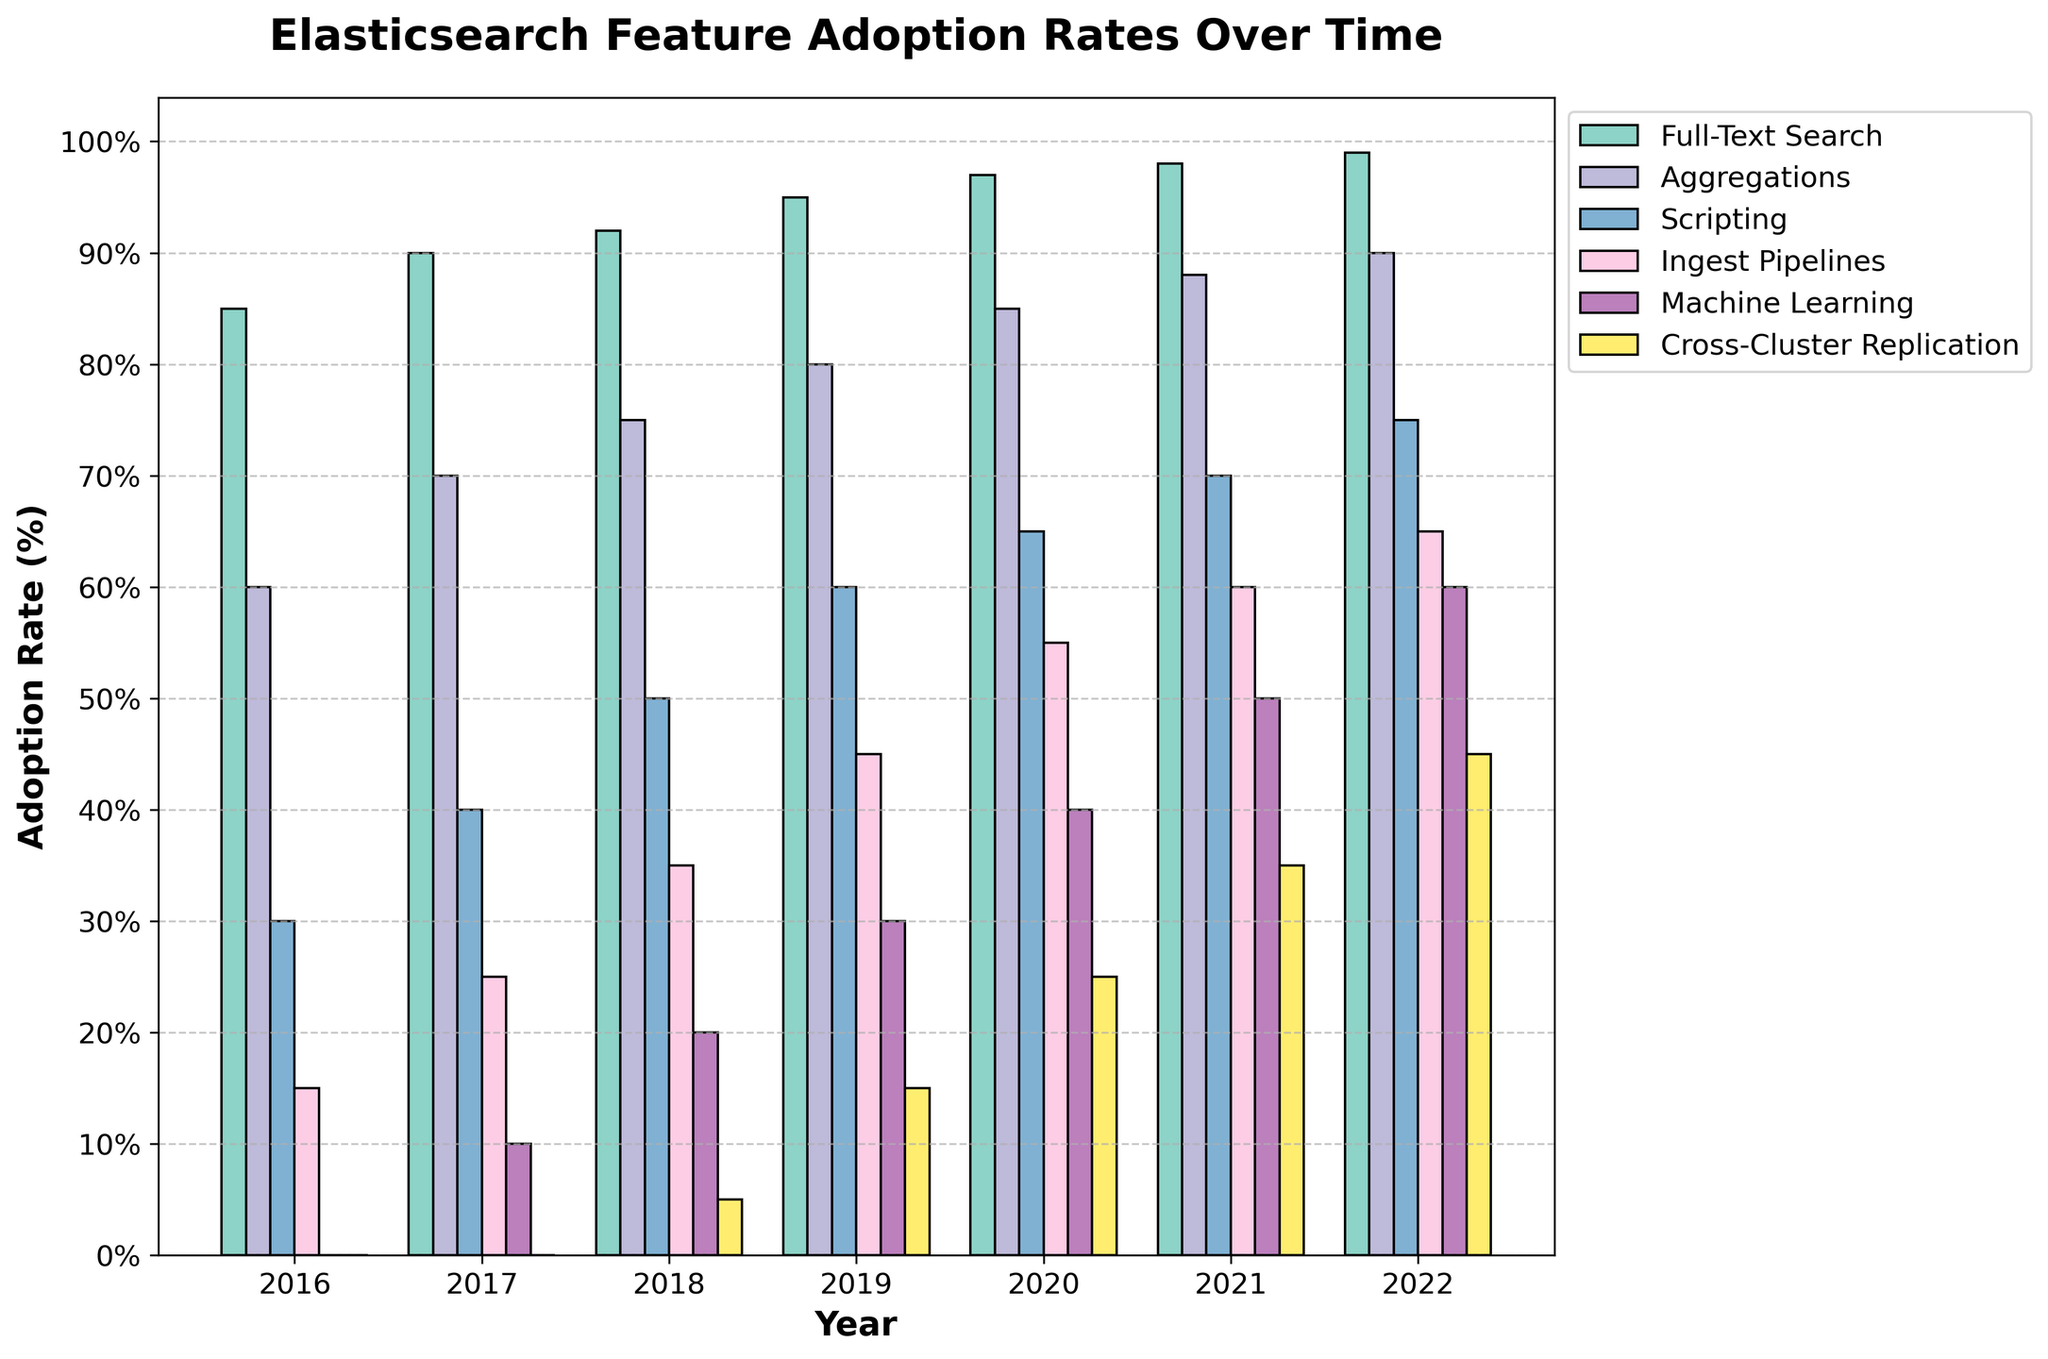Which feature had the highest adoption rate in 2016? Look at the bars for the year 2016 and compare their heights. The bar for Full-Text Search is the highest in 2016.
Answer: Full-Text Search How many features had an adoption rate of at least 60% in 2021? Count the number of bars for the year 2021 that are at or above the 60% mark. There are four bars at or above this level (Full-Text Search, Aggregations, Scripting, and Ingest Pipelines).
Answer: Four What’s the difference in adoption rates between Machine Learning and Cross-Cluster Replication in 2022? Find the height of the bars for Machine Learning and Cross-Cluster Replication in 2022. Machine Learning is at 60%, and Cross-Cluster Replication is at 45%. The difference is 60% - 45% = 15%.
Answer: 15% Which feature showed the greatest increase in adoption rate from 2016 to 2022? Check the difference in heights of each feature’s bar from 2016 to 2022. The greatest difference is for Full-Text Search, which increased from 85% to 99%, an increase of 14%.
Answer: Full-Text Search In what year did Ingest Pipelines reach a 50% adoption rate? Look at the bars for Ingest Pipelines across the years. The bar reaches 50% in 2020.
Answer: 2020 Which feature had the slowest adoption rate growth between 2016 and 2017? Compare the increase in bar heights for each feature from 2016 to 2017. The slowest increase is for Full-Text Search, which increased by 5%.
Answer: Full-Text Search What is the average adoption rate of Aggregations over the years 2018 to 2022? Summing the adoption rates of Aggregations from 2018 to 2022 gives 75 + 80 + 85 + 88 + 90 = 418. Dividing by the number of years (5) gives 418 / 5 = 83.6%.
Answer: 83.6% How much did the adoption rate of Scripting increase between 2017 and 2018? Calculate the difference in the heights of the bars for Scripting between 2017 and 2018. The adoption rate increased from 40% to 50%, so the difference is 50% - 40% = 10%.
Answer: 10% Which year shows the highest diversity in feature adoption rates? Diversity in adoption rates can be inferred from the range (difference between the highest and lowest values) for each year. 2019 shows the most significant range, with the adoption rates varying from 15% (Cross-Cluster Replication) to 95% (Full-Text Search).
Answer: 2019 